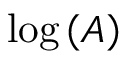Convert formula to latex. <formula><loc_0><loc_0><loc_500><loc_500>\log \left ( A \right )</formula> 